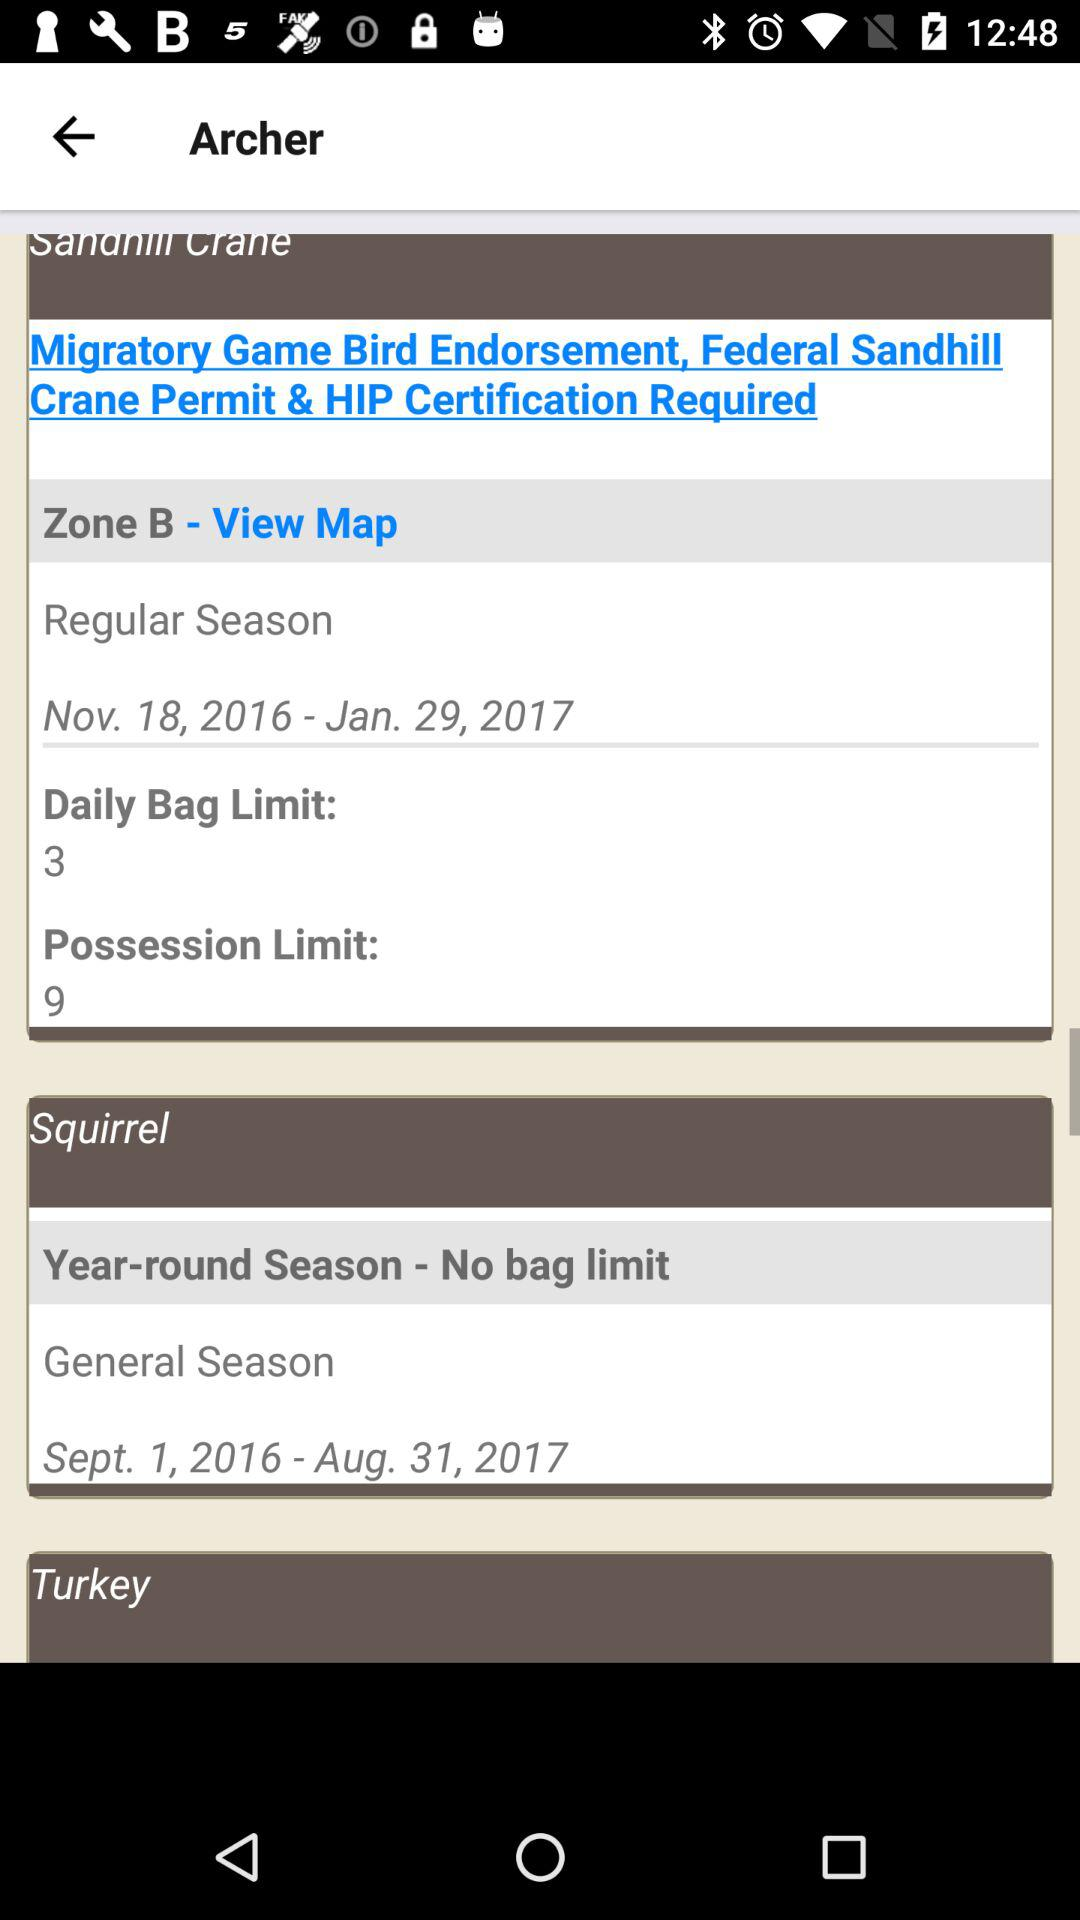When is the general season? The general season is from September 1, 2016 to August 31, 2017. 